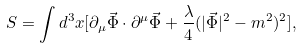Convert formula to latex. <formula><loc_0><loc_0><loc_500><loc_500>S = \int d ^ { 3 } x [ \partial _ { \mu } \vec { \Phi } \cdot \partial ^ { \mu } \vec { \Phi } + \frac { \lambda } { 4 } ( | \vec { \Phi } | ^ { 2 } - m ^ { 2 } ) ^ { 2 } ] ,</formula> 